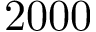<formula> <loc_0><loc_0><loc_500><loc_500>2 0 0 0</formula> 